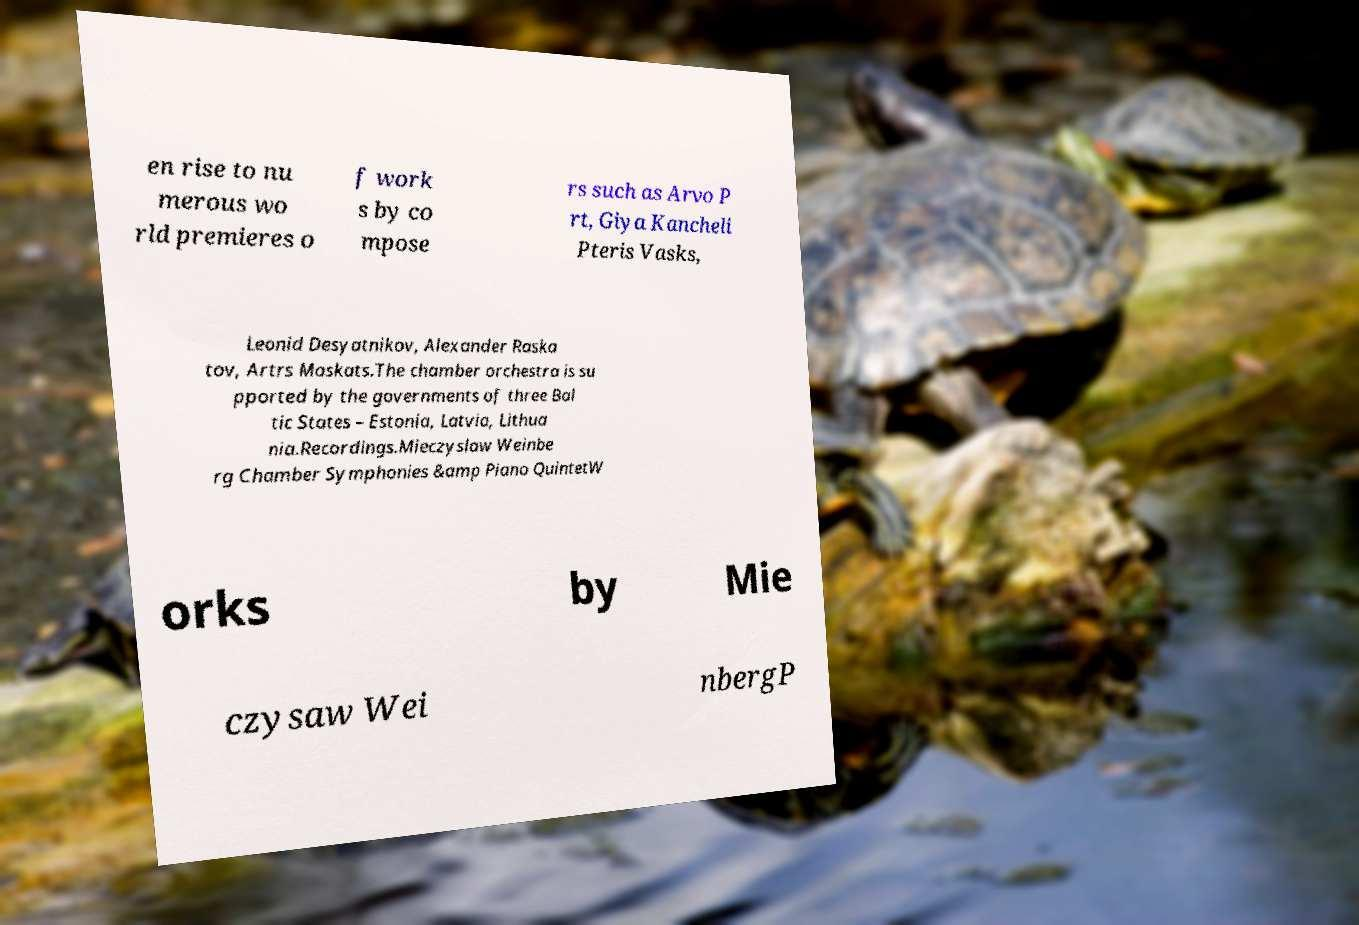There's text embedded in this image that I need extracted. Can you transcribe it verbatim? en rise to nu merous wo rld premieres o f work s by co mpose rs such as Arvo P rt, Giya Kancheli Pteris Vasks, Leonid Desyatnikov, Alexander Raska tov, Artrs Maskats.The chamber orchestra is su pported by the governments of three Bal tic States – Estonia, Latvia, Lithua nia.Recordings.Mieczyslaw Weinbe rg Chamber Symphonies &amp Piano QuintetW orks by Mie czysaw Wei nbergP 